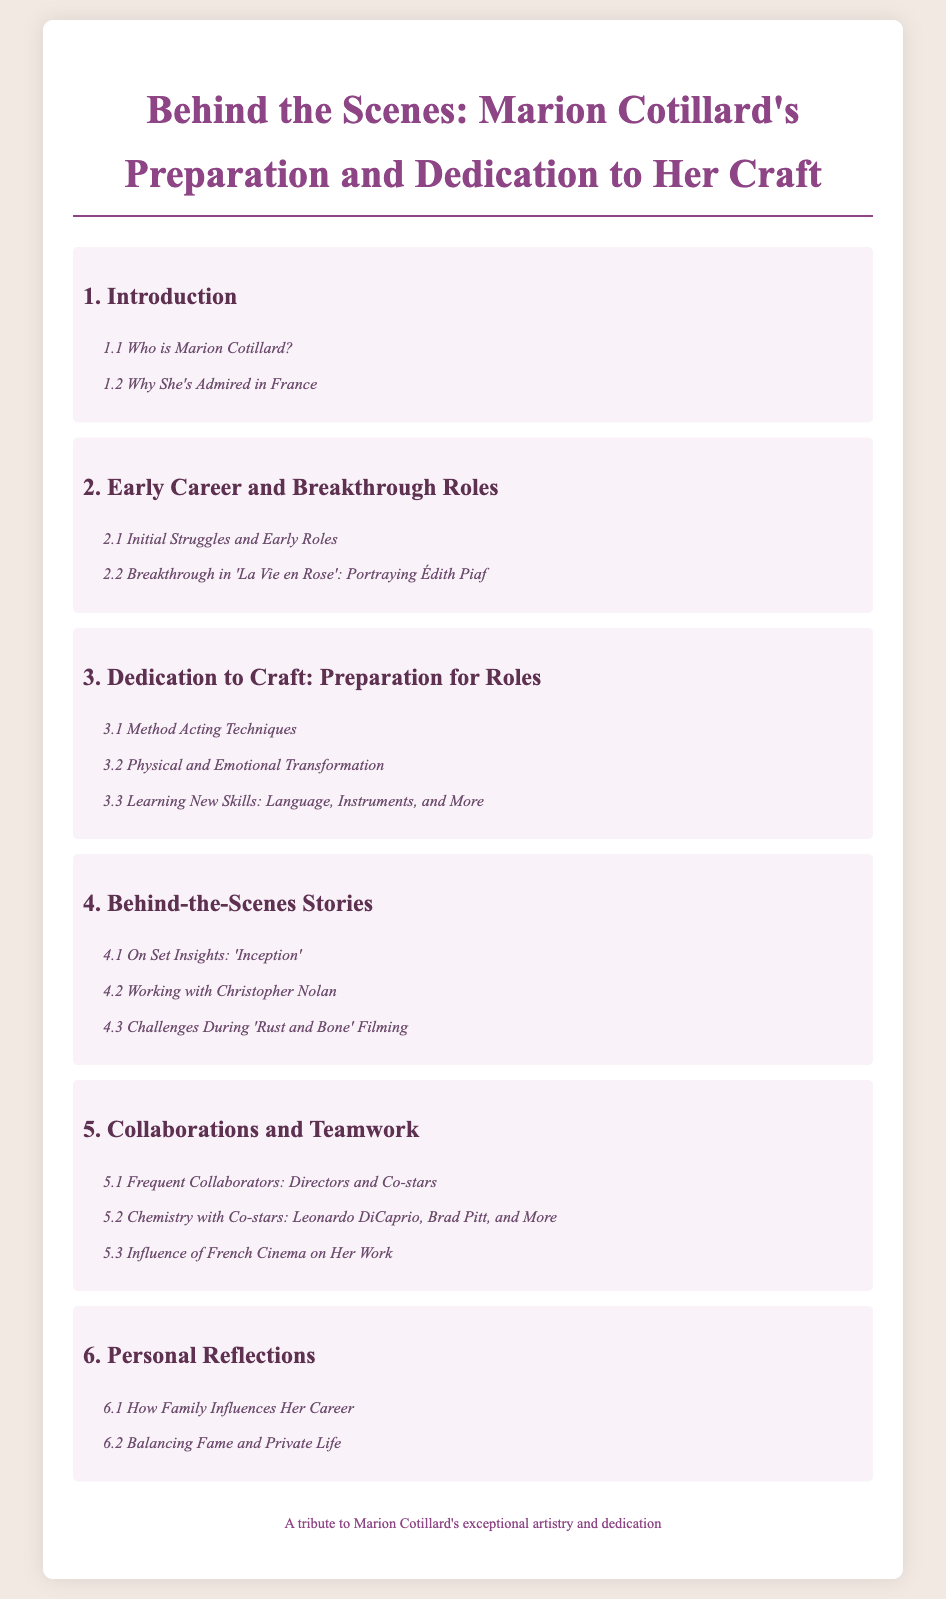What is the title of the document? The title of the document is indicated at the top of the rendered HTML, specifically stated as the main heading.
Answer: Behind the Scenes: Marion Cotillard's Preparation and Dedication to Her Craft Who is Marion Cotillard? The document provides a section specifically about her identity within the introductory chapter.
Answer: Section 1.1 What was Marion Cotillard's breakthrough role? The document mentions her breakthrough role in Chapter 2, highlighting a specific film where she gained fame.
Answer: La Vie en Rose How many sections are in Chapter 3? The number of sections within Chapter 3 can be counted in the corresponding list provided in the document.
Answer: 3 Which director is mentioned in relation to behind-the-scenes stories? The document notes specific directors in Chapter 4, highlighting collaboration details.
Answer: Christopher Nolan What skill does Marion Cotillard learn for her roles? Chapter 3 discusses various new skills she acquires for her roles, one being language skills explicitly noted.
Answer: Language How does Marion Cotillard balance aspects of her life? The document includes a section in Chapter 6 discussing how she manages different facets of her life.
Answer: Balancing Fame and Private Life What does the document acknowledge about Marion Cotillard's family? In Chapter 6, the document addresses the influence of her family on her professional life.
Answer: How Family Influences Her Career How many chapters are in the document? The document's table of contents lists all the chapters sequentially, providing a total count.
Answer: 6 